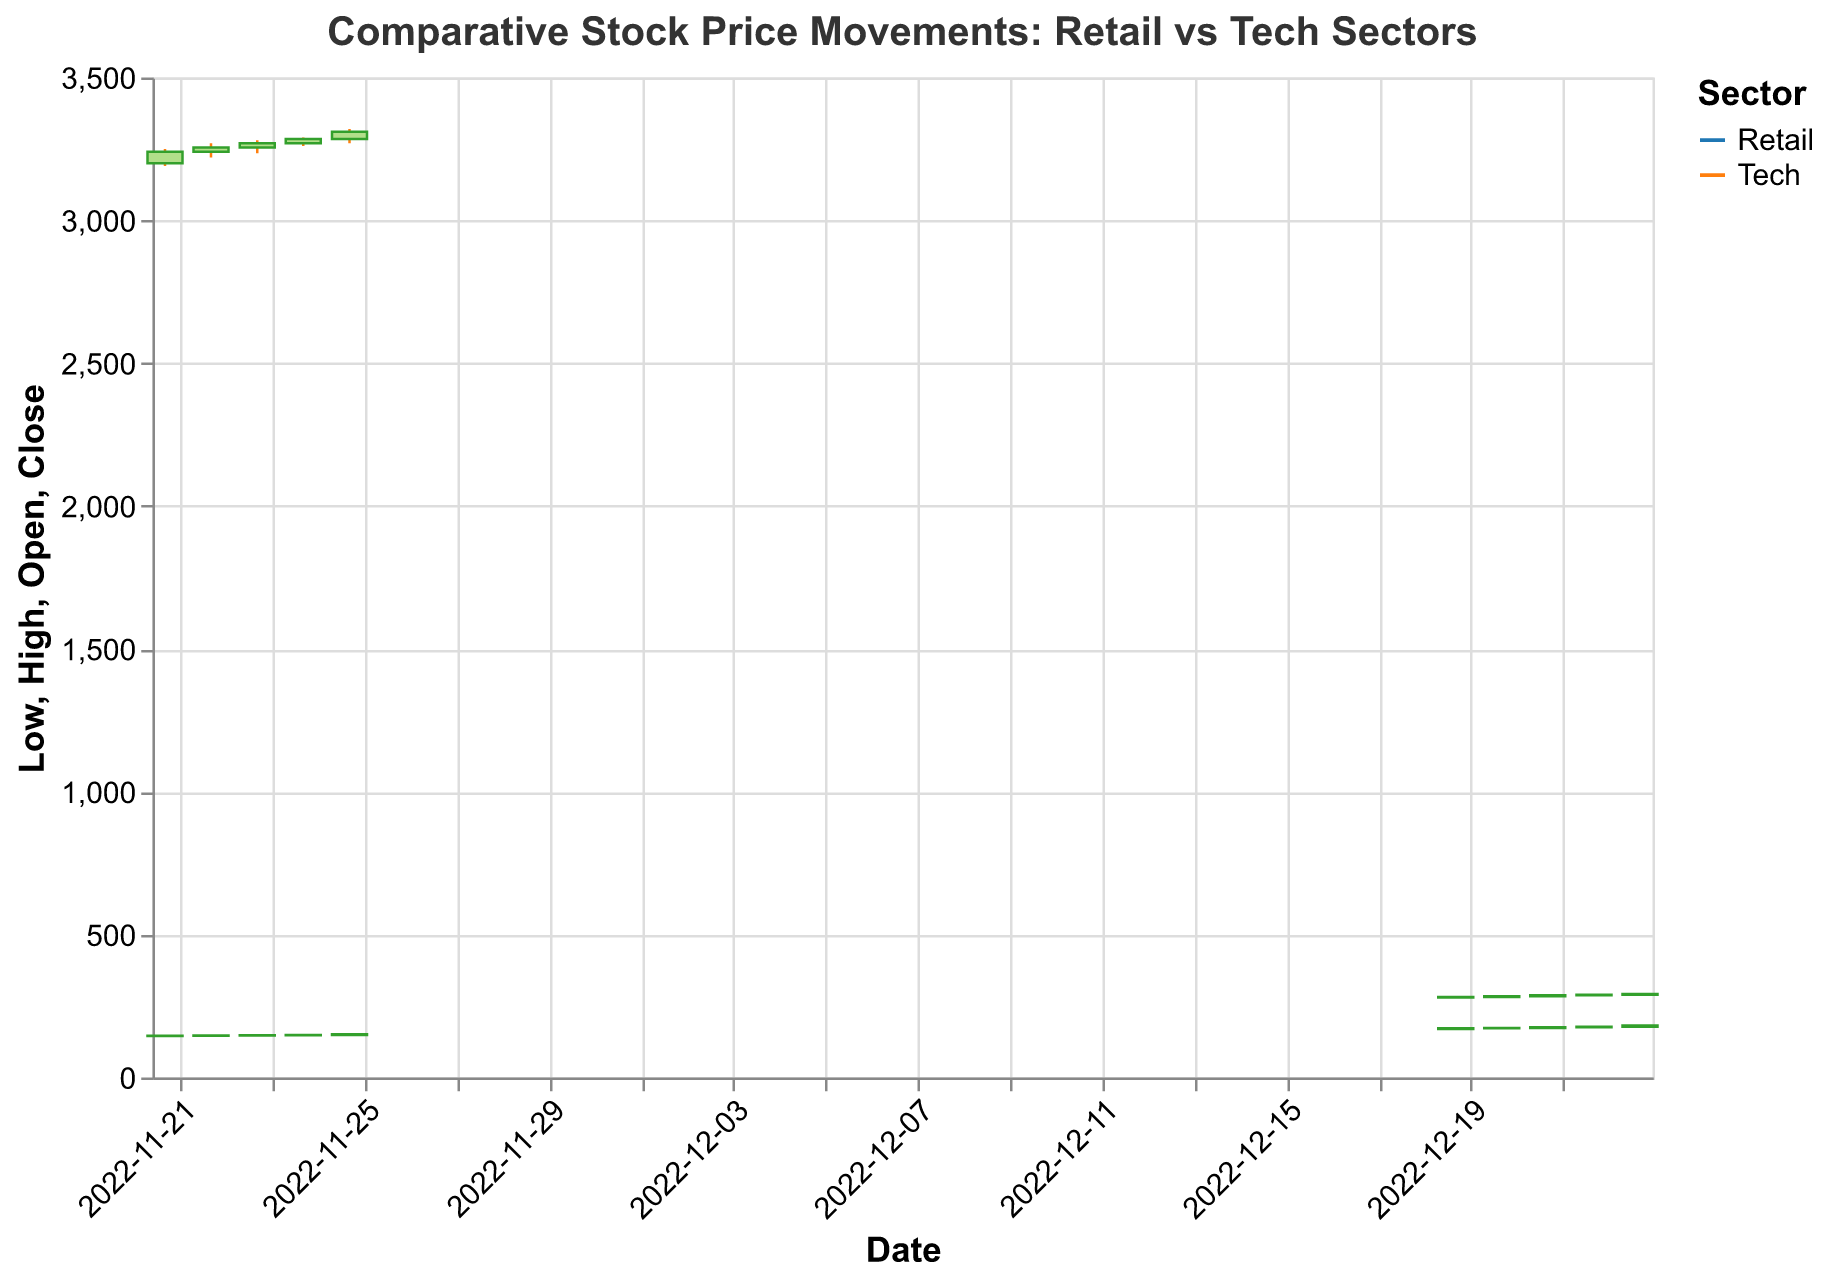What is the highest closing price for Amazon during the time period shown? Look at the candlestick representing Amazon's daily stock performance; the highest closing price is shown as the topmost part of each bar. The highest closing price for Amazon is found on 2022-11-25 at 3310.
Answer: 3310 What is the lowest opening price for Walmart during the time period shown? Look at the candlestick representing Walmart's daily stock performance; the lowest value is the bottom of the corresponding day's bar for the "Open" price. The lowest opening price for Walmart is 145 on 2022-11-21.
Answer: 145 Which company in the retail sector had the largest price increase from opening to closing on any single day? Look at the bars representing each retail company's daily stock performance; the company with the largest change between "Open" and "Close" indicates the largest price increase. Target on 2022-12-21 showed an increase from 173 to 176 (3 units).
Answer: Target Did Microsoft or Amazon have larger average daily trading volumes over the period shown? Calculate the average volume for both companies by adding their daily volumes and dividing by the number of days. Microsoft's daily volumes sum to 28,350,000 and over 5 days, the average is 28,350,000 / 5 = 5,670,000. Amazon's daily volumes sum to 24,550,000 and over 5 days, the average is 24,550,000 / 5 = 4,910,000.
Answer: Microsoft Between the retail and tech sectors, which saw greater volatility in daily highs and lows during their respective periods? (define volatility as the difference between high and low prices) For each sector, calculate the average difference between "High" and "Low" prices over the time period. For Tech (using Microsoft and Amazon): average ((285-278) + (287-280) + (290-282) + (292-286) + (295-288) + (3250-3190) + (3270-3220) + (3280-3235) + (3290-3260) + (3320-3270)) / 10 = 6. For Retail (using Walmart and Target): average ((148-143) + (149-144) + (150-145) + (151-146) + (152-147) + (173-168) + (175-170) + (178-171) + (180-174) + (183-176)) / 10 = 5.6.
Answer: Tech Which day had the largest trading volume across all companies? Look at the "Volume" for each day and identify the day with the highest trading volume by summing up volumes of all companies for each date. The highest trading volume is on 2022-11-22 with 5100000 (Amazon) + 8200000 (Walmart) = 13,300,000.
Answer: 2022-11-22 Did Target or Walmart show more consistent price increases from opening to closing over their respective periods? Compare the sequence of daily closing prices with opening prices for Target and Walmart over their respective periods. Target shows consistent increases every day (opening and closing prices increase each day from 170 to 182). Walmart's closing prices increased steadily but less consistently compared to Target.
Answer: Target What was the largest drop in stock price for any company in one day? Compare the difference between "High" and "Low" prices for each company on each day. The largest drop is 60 units for Amazon (from 3250 to 3190) on 2022-11-21.
Answer: Amazon 